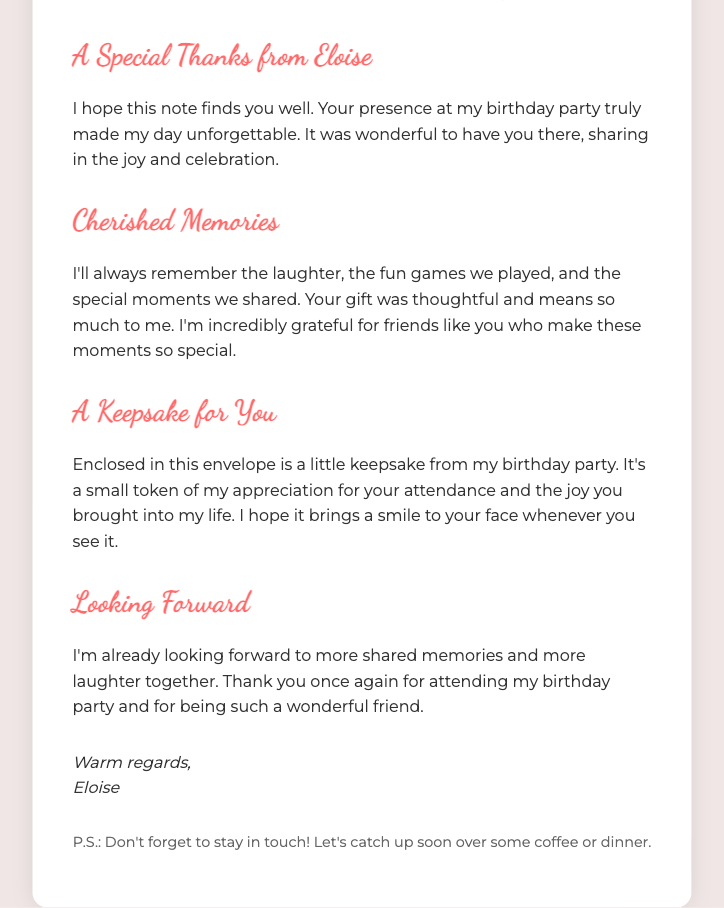What is the purpose of the note? The note expresses gratitude for attending Eloise's birthday party.
Answer: Gratitude Who is the note addressed to? The note is addressed to a friend whose name is indicated by [Friend's Name].
Answer: [Friend's Name] What will the recipient find enclosed in the envelope? There is a keepsake from the birthday party enclosed in the envelope.
Answer: A keepsake What memory does Eloise cherish from the party? Eloise mentions cherishing the laughter and fun games played during the party.
Answer: Laughter and fun games What does Eloise invite the recipient to do? Eloise invites the recipient to catch up over coffee or dinner.
Answer: Catch up over coffee or dinner 